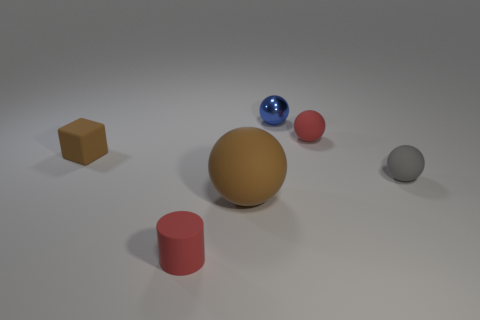Is there another small red object of the same shape as the metal thing?
Offer a terse response. Yes. Is the size of the matte sphere on the left side of the shiny ball the same as the tiny brown rubber block?
Provide a short and direct response. No. There is a thing that is both left of the brown sphere and behind the small red matte cylinder; what is its size?
Offer a terse response. Small. How many other objects are the same material as the red sphere?
Ensure brevity in your answer.  4. How big is the rubber object that is left of the tiny cylinder?
Your response must be concise. Small. Do the large object and the rubber block have the same color?
Ensure brevity in your answer.  Yes. How many large objects are red rubber spheres or blue metallic cylinders?
Provide a short and direct response. 0. Is there any other thing that is the same color as the cube?
Offer a very short reply. Yes. There is a tiny brown rubber object; are there any large balls to the left of it?
Your response must be concise. No. There is a red rubber object that is right of the matte ball that is in front of the gray rubber sphere; what is its size?
Offer a terse response. Small. 